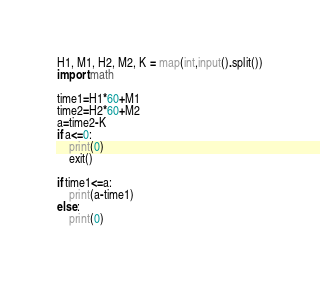Convert code to text. <code><loc_0><loc_0><loc_500><loc_500><_Python_>H1, M1, H2, M2, K = map(int,input().split())
import math

time1=H1*60+M1
time2=H2*60+M2
a=time2-K
if a<=0:
    print(0)
    exit()

if time1<=a:
    print(a-time1)
else:
    print(0)</code> 